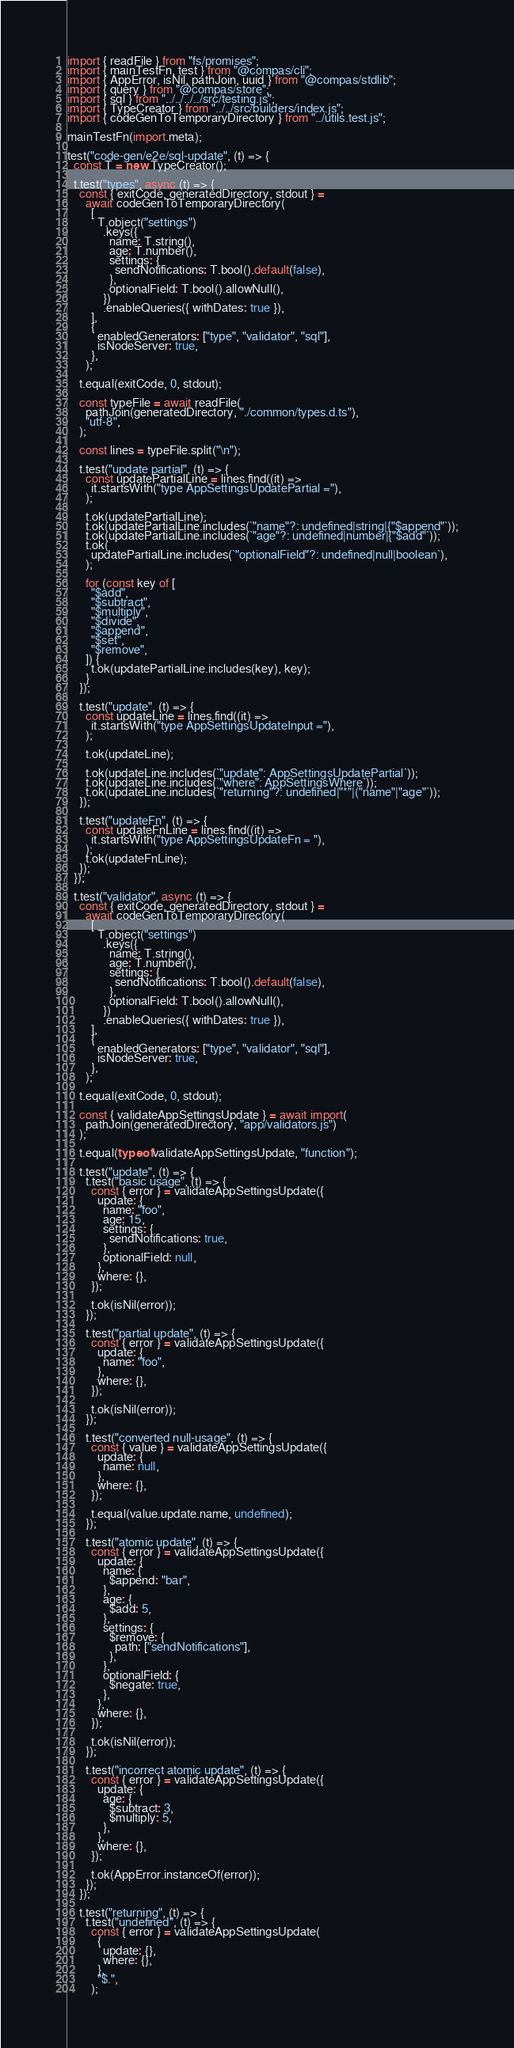<code> <loc_0><loc_0><loc_500><loc_500><_JavaScript_>import { readFile } from "fs/promises";
import { mainTestFn, test } from "@compas/cli";
import { AppError, isNil, pathJoin, uuid } from "@compas/stdlib";
import { query } from "@compas/store";
import { sql } from "../../../../src/testing.js";
import { TypeCreator } from "../../src/builders/index.js";
import { codeGenToTemporaryDirectory } from "../utils.test.js";

mainTestFn(import.meta);

test("code-gen/e2e/sql-update", (t) => {
  const T = new TypeCreator();

  t.test("types", async (t) => {
    const { exitCode, generatedDirectory, stdout } =
      await codeGenToTemporaryDirectory(
        [
          T.object("settings")
            .keys({
              name: T.string(),
              age: T.number(),
              settings: {
                sendNotifications: T.bool().default(false),
              },
              optionalField: T.bool().allowNull(),
            })
            .enableQueries({ withDates: true }),
        ],
        {
          enabledGenerators: ["type", "validator", "sql"],
          isNodeServer: true,
        },
      );

    t.equal(exitCode, 0, stdout);

    const typeFile = await readFile(
      pathJoin(generatedDirectory, "./common/types.d.ts"),
      "utf-8",
    );

    const lines = typeFile.split("\n");

    t.test("update partial", (t) => {
      const updatePartialLine = lines.find((it) =>
        it.startsWith("type AppSettingsUpdatePartial ="),
      );

      t.ok(updatePartialLine);
      t.ok(updatePartialLine.includes(`"name"?: undefined|string|{"$append"`));
      t.ok(updatePartialLine.includes(`"age"?: undefined|number|{"$add"`));
      t.ok(
        updatePartialLine.includes(`"optionalField"?: undefined|null|boolean`),
      );

      for (const key of [
        "$add",
        "$subtract",
        "$multiply",
        "$divide",
        "$append",
        "$set",
        "$remove",
      ]) {
        t.ok(updatePartialLine.includes(key), key);
      }
    });

    t.test("update", (t) => {
      const updateLine = lines.find((it) =>
        it.startsWith("type AppSettingsUpdateInput ="),
      );

      t.ok(updateLine);

      t.ok(updateLine.includes(`"update": AppSettingsUpdatePartial`));
      t.ok(updateLine.includes(`"where": AppSettingsWhere`));
      t.ok(updateLine.includes(`"returning"?: undefined|"*"|("name"|"age"`));
    });

    t.test("updateFn", (t) => {
      const updateFnLine = lines.find((it) =>
        it.startsWith("type AppSettingsUpdateFn = "),
      );
      t.ok(updateFnLine);
    });
  });

  t.test("validator", async (t) => {
    const { exitCode, generatedDirectory, stdout } =
      await codeGenToTemporaryDirectory(
        [
          T.object("settings")
            .keys({
              name: T.string(),
              age: T.number(),
              settings: {
                sendNotifications: T.bool().default(false),
              },
              optionalField: T.bool().allowNull(),
            })
            .enableQueries({ withDates: true }),
        ],
        {
          enabledGenerators: ["type", "validator", "sql"],
          isNodeServer: true,
        },
      );

    t.equal(exitCode, 0, stdout);

    const { validateAppSettingsUpdate } = await import(
      pathJoin(generatedDirectory, "app/validators.js")
    );

    t.equal(typeof validateAppSettingsUpdate, "function");

    t.test("update", (t) => {
      t.test("basic usage", (t) => {
        const { error } = validateAppSettingsUpdate({
          update: {
            name: "foo",
            age: 15,
            settings: {
              sendNotifications: true,
            },
            optionalField: null,
          },
          where: {},
        });

        t.ok(isNil(error));
      });

      t.test("partial update", (t) => {
        const { error } = validateAppSettingsUpdate({
          update: {
            name: "foo",
          },
          where: {},
        });

        t.ok(isNil(error));
      });

      t.test("converted null-usage", (t) => {
        const { value } = validateAppSettingsUpdate({
          update: {
            name: null,
          },
          where: {},
        });

        t.equal(value.update.name, undefined);
      });

      t.test("atomic update", (t) => {
        const { error } = validateAppSettingsUpdate({
          update: {
            name: {
              $append: "bar",
            },
            age: {
              $add: 5,
            },
            settings: {
              $remove: {
                path: ["sendNotifications"],
              },
            },
            optionalField: {
              $negate: true,
            },
          },
          where: {},
        });

        t.ok(isNil(error));
      });

      t.test("incorrect atomic update", (t) => {
        const { error } = validateAppSettingsUpdate({
          update: {
            age: {
              $subtract: 3,
              $multiply: 5,
            },
          },
          where: {},
        });

        t.ok(AppError.instanceOf(error));
      });
    });

    t.test("returning", (t) => {
      t.test("undefined", (t) => {
        const { error } = validateAppSettingsUpdate(
          {
            update: {},
            where: {},
          },
          "$.",
        );
</code> 